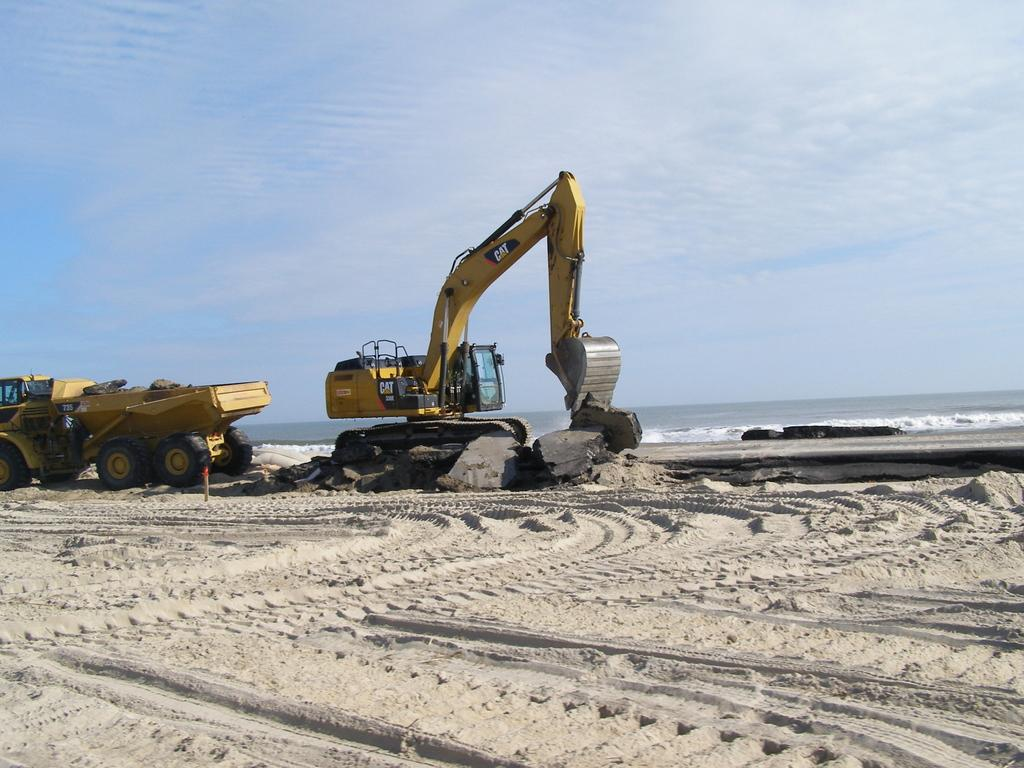What type of surface is shown in the image? The image shows a sand surface. What vehicle is on the sand surface? There is a truck on the sand surface. What type of equipment is present in the image? Removing equipment is present in the image. What can be seen in the background of the image? Water and the sky are visible in the background. What is the condition of the sky in the image? Clouds are present in the sky. Can you see the toes of the people operating the removing equipment in the image? There are no people visible in the image, so it is not possible to see their toes. Is there a shop selling stoves in the background of the image? There is no shop or stove present in the image; it only shows a sand surface, a truck, removing equipment, water, and the sky. 